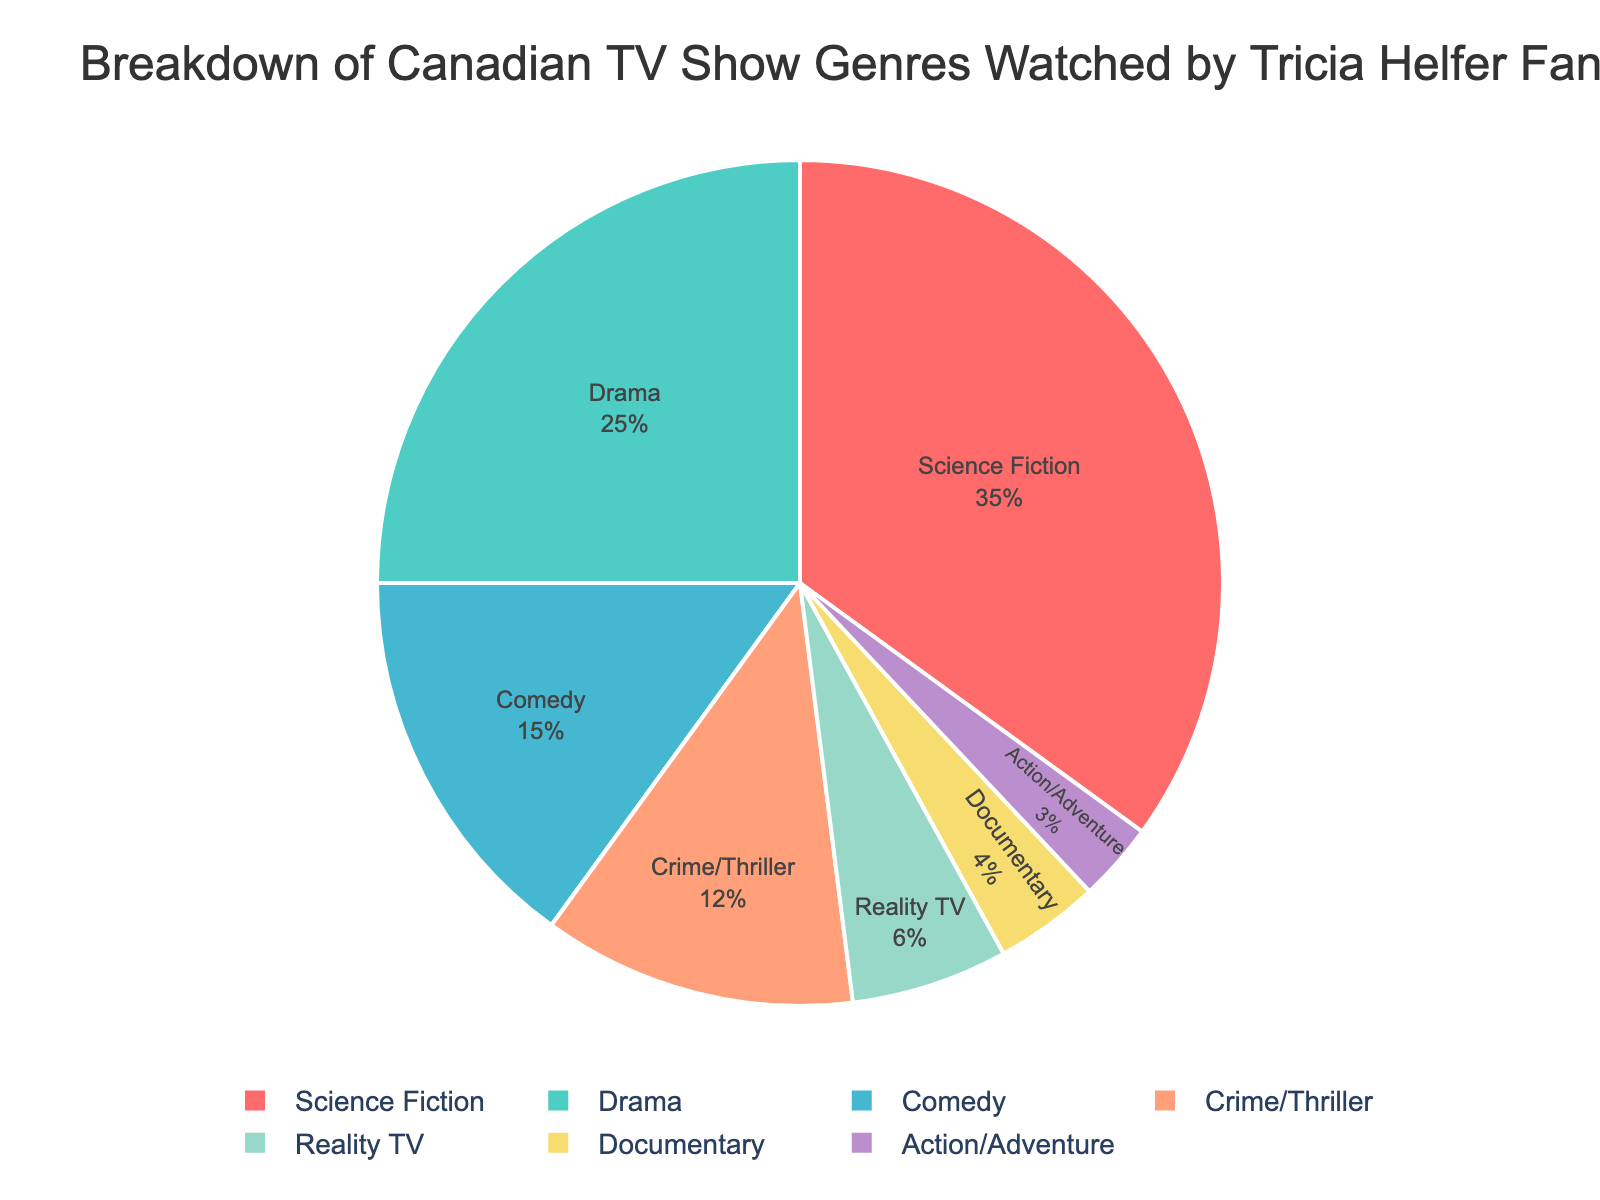What genre has the highest percentage of viewership among Tricia Helfer fans? Looking at the pie chart, the largest slice represents Science Fiction. Its percentage is 35%.
Answer: Science Fiction Which two genres have the smallest percentage of viewership? The smallest slices of the pie chart correspond to Documentary and Action/Adventure, with percentages of 4% and 3% respectively.
Answer: Documentary and Action/Adventure By how much does the percentage of Drama exceed that of Comedy? Drama has a percentage of 25%, and Comedy has 15%. Subtract 15 from 25 to find the difference: 25 - 15 = 10%.
Answer: 10% What is the combined viewership percentage of Crime/Thriller and Reality TV? Crime/Thriller has a percentage of 12% and Reality TV has 6%. Add these two percentages together: 12 + 6 = 18%.
Answer: 18% How much more popular is Science Fiction compared to Reality TV? Science Fiction has a percentage of 35%, and Reality TV has 6%. Subtract 6 from 35 to find the difference: 35 - 6 = 29%.
Answer: 29% Between Drama and Comedy, which genre do Tricia Helfer fans prefer more, and by how much? Drama has a percentage of 25%, while Comedy has 15%. Since 25 is greater than 15, Drama is preferred by 10% more: 25 - 15 = 10%.
Answer: Drama by 10% What percentage of Tricia Helfer fans watched genres other than Science Fiction? Science Fiction accounts for 35% of viewership. Subtract 35% from 100% to find the percentage of other genres: 100 - 35 = 65%.
Answer: 65% Comparing Documentary to Action/Adventure, which has a higher percentage and by what amount? Documentary has a percentage of 4%, while Action/Adventure has 3%. 4% is higher than 3% by 1%: 4 - 3 = 1%.
Answer: Documentary by 1% What is the total percentage of viewership for the top three genres? The top three genres are Science Fiction (35%), Drama (25%), and Comedy (15%). Adding these percentages together: 35 + 25 + 15 = 75%.
Answer: 75% 